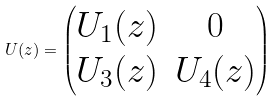<formula> <loc_0><loc_0><loc_500><loc_500>U ( z ) = \begin{pmatrix} U _ { 1 } ( z ) & 0 \\ U _ { 3 } ( z ) & U _ { 4 } ( z ) \end{pmatrix}</formula> 